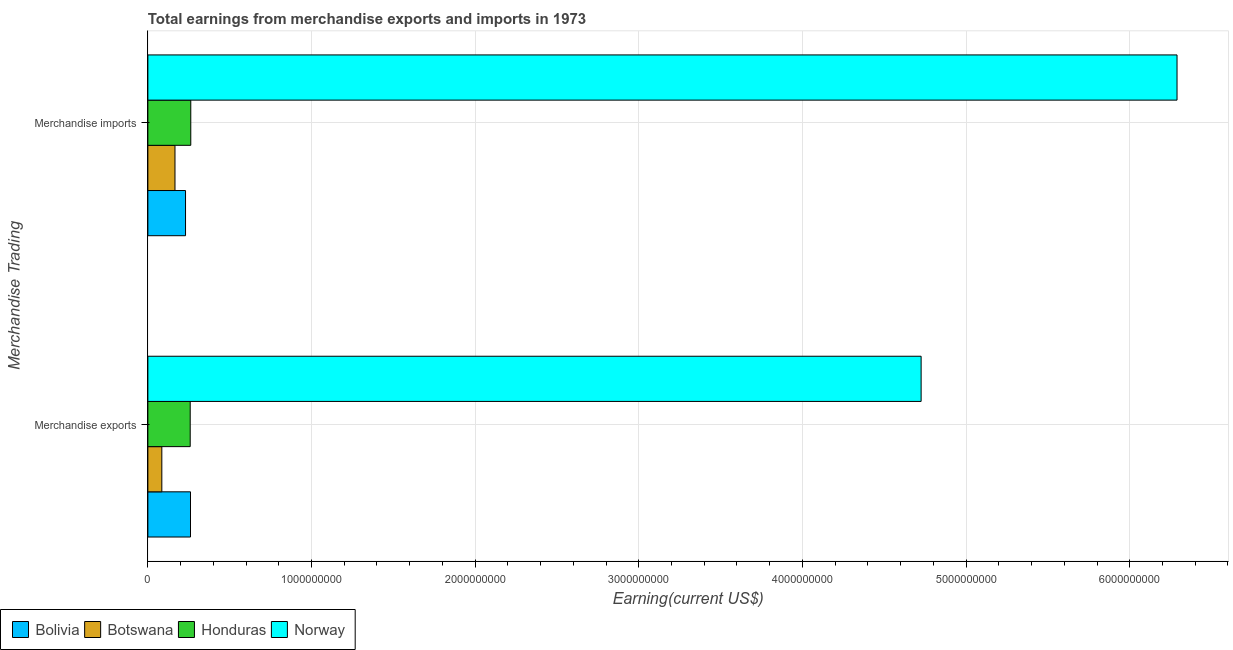How many different coloured bars are there?
Provide a succinct answer. 4. How many groups of bars are there?
Offer a terse response. 2. How many bars are there on the 1st tick from the top?
Provide a short and direct response. 4. What is the earnings from merchandise imports in Honduras?
Offer a very short reply. 2.62e+08. Across all countries, what is the maximum earnings from merchandise imports?
Keep it short and to the point. 6.29e+09. Across all countries, what is the minimum earnings from merchandise imports?
Make the answer very short. 1.66e+08. In which country was the earnings from merchandise exports maximum?
Make the answer very short. Norway. In which country was the earnings from merchandise imports minimum?
Your response must be concise. Botswana. What is the total earnings from merchandise imports in the graph?
Provide a succinct answer. 6.95e+09. What is the difference between the earnings from merchandise imports in Bolivia and that in Botswana?
Offer a very short reply. 6.45e+07. What is the difference between the earnings from merchandise exports in Botswana and the earnings from merchandise imports in Bolivia?
Your answer should be compact. -1.45e+08. What is the average earnings from merchandise imports per country?
Give a very brief answer. 1.74e+09. What is the difference between the earnings from merchandise exports and earnings from merchandise imports in Honduras?
Give a very brief answer. -3.54e+06. In how many countries, is the earnings from merchandise exports greater than 5800000000 US$?
Your response must be concise. 0. What is the ratio of the earnings from merchandise imports in Botswana to that in Norway?
Offer a very short reply. 0.03. In how many countries, is the earnings from merchandise imports greater than the average earnings from merchandise imports taken over all countries?
Provide a short and direct response. 1. What does the 2nd bar from the top in Merchandise exports represents?
Ensure brevity in your answer.  Honduras. What does the 3rd bar from the bottom in Merchandise exports represents?
Your answer should be compact. Honduras. Are all the bars in the graph horizontal?
Offer a very short reply. Yes. How many countries are there in the graph?
Keep it short and to the point. 4. What is the difference between two consecutive major ticks on the X-axis?
Ensure brevity in your answer.  1.00e+09. Does the graph contain any zero values?
Your answer should be compact. No. Does the graph contain grids?
Offer a very short reply. Yes. How many legend labels are there?
Your response must be concise. 4. What is the title of the graph?
Your answer should be very brief. Total earnings from merchandise exports and imports in 1973. Does "Sudan" appear as one of the legend labels in the graph?
Provide a succinct answer. No. What is the label or title of the X-axis?
Ensure brevity in your answer.  Earning(current US$). What is the label or title of the Y-axis?
Provide a succinct answer. Merchandise Trading. What is the Earning(current US$) of Bolivia in Merchandise exports?
Provide a short and direct response. 2.60e+08. What is the Earning(current US$) in Botswana in Merchandise exports?
Give a very brief answer. 8.53e+07. What is the Earning(current US$) of Honduras in Merchandise exports?
Your answer should be very brief. 2.59e+08. What is the Earning(current US$) in Norway in Merchandise exports?
Make the answer very short. 4.73e+09. What is the Earning(current US$) of Bolivia in Merchandise imports?
Make the answer very short. 2.30e+08. What is the Earning(current US$) in Botswana in Merchandise imports?
Your answer should be very brief. 1.66e+08. What is the Earning(current US$) of Honduras in Merchandise imports?
Make the answer very short. 2.62e+08. What is the Earning(current US$) of Norway in Merchandise imports?
Your response must be concise. 6.29e+09. Across all Merchandise Trading, what is the maximum Earning(current US$) in Bolivia?
Your answer should be compact. 2.60e+08. Across all Merchandise Trading, what is the maximum Earning(current US$) of Botswana?
Your answer should be compact. 1.66e+08. Across all Merchandise Trading, what is the maximum Earning(current US$) in Honduras?
Offer a very short reply. 2.62e+08. Across all Merchandise Trading, what is the maximum Earning(current US$) in Norway?
Give a very brief answer. 6.29e+09. Across all Merchandise Trading, what is the minimum Earning(current US$) of Bolivia?
Provide a succinct answer. 2.30e+08. Across all Merchandise Trading, what is the minimum Earning(current US$) in Botswana?
Make the answer very short. 8.53e+07. Across all Merchandise Trading, what is the minimum Earning(current US$) in Honduras?
Give a very brief answer. 2.59e+08. Across all Merchandise Trading, what is the minimum Earning(current US$) in Norway?
Make the answer very short. 4.73e+09. What is the total Earning(current US$) of Bolivia in the graph?
Provide a short and direct response. 4.91e+08. What is the total Earning(current US$) of Botswana in the graph?
Give a very brief answer. 2.51e+08. What is the total Earning(current US$) of Honduras in the graph?
Provide a short and direct response. 5.21e+08. What is the total Earning(current US$) in Norway in the graph?
Provide a short and direct response. 1.10e+1. What is the difference between the Earning(current US$) in Bolivia in Merchandise exports and that in Merchandise imports?
Offer a terse response. 3.03e+07. What is the difference between the Earning(current US$) of Botswana in Merchandise exports and that in Merchandise imports?
Offer a very short reply. -8.04e+07. What is the difference between the Earning(current US$) in Honduras in Merchandise exports and that in Merchandise imports?
Keep it short and to the point. -3.54e+06. What is the difference between the Earning(current US$) in Norway in Merchandise exports and that in Merchandise imports?
Give a very brief answer. -1.56e+09. What is the difference between the Earning(current US$) of Bolivia in Merchandise exports and the Earning(current US$) of Botswana in Merchandise imports?
Your answer should be compact. 9.48e+07. What is the difference between the Earning(current US$) in Bolivia in Merchandise exports and the Earning(current US$) in Honduras in Merchandise imports?
Offer a terse response. -1.78e+06. What is the difference between the Earning(current US$) in Bolivia in Merchandise exports and the Earning(current US$) in Norway in Merchandise imports?
Offer a very short reply. -6.03e+09. What is the difference between the Earning(current US$) in Botswana in Merchandise exports and the Earning(current US$) in Honduras in Merchandise imports?
Ensure brevity in your answer.  -1.77e+08. What is the difference between the Earning(current US$) of Botswana in Merchandise exports and the Earning(current US$) of Norway in Merchandise imports?
Your response must be concise. -6.20e+09. What is the difference between the Earning(current US$) in Honduras in Merchandise exports and the Earning(current US$) in Norway in Merchandise imports?
Make the answer very short. -6.03e+09. What is the average Earning(current US$) of Bolivia per Merchandise Trading?
Give a very brief answer. 2.45e+08. What is the average Earning(current US$) of Botswana per Merchandise Trading?
Give a very brief answer. 1.25e+08. What is the average Earning(current US$) of Honduras per Merchandise Trading?
Your response must be concise. 2.61e+08. What is the average Earning(current US$) in Norway per Merchandise Trading?
Your answer should be compact. 5.51e+09. What is the difference between the Earning(current US$) of Bolivia and Earning(current US$) of Botswana in Merchandise exports?
Your answer should be very brief. 1.75e+08. What is the difference between the Earning(current US$) in Bolivia and Earning(current US$) in Honduras in Merchandise exports?
Your answer should be compact. 1.76e+06. What is the difference between the Earning(current US$) of Bolivia and Earning(current US$) of Norway in Merchandise exports?
Give a very brief answer. -4.46e+09. What is the difference between the Earning(current US$) in Botswana and Earning(current US$) in Honduras in Merchandise exports?
Offer a very short reply. -1.73e+08. What is the difference between the Earning(current US$) of Botswana and Earning(current US$) of Norway in Merchandise exports?
Give a very brief answer. -4.64e+09. What is the difference between the Earning(current US$) of Honduras and Earning(current US$) of Norway in Merchandise exports?
Offer a very short reply. -4.47e+09. What is the difference between the Earning(current US$) of Bolivia and Earning(current US$) of Botswana in Merchandise imports?
Provide a succinct answer. 6.45e+07. What is the difference between the Earning(current US$) of Bolivia and Earning(current US$) of Honduras in Merchandise imports?
Keep it short and to the point. -3.21e+07. What is the difference between the Earning(current US$) in Bolivia and Earning(current US$) in Norway in Merchandise imports?
Make the answer very short. -6.06e+09. What is the difference between the Earning(current US$) of Botswana and Earning(current US$) of Honduras in Merchandise imports?
Ensure brevity in your answer.  -9.66e+07. What is the difference between the Earning(current US$) in Botswana and Earning(current US$) in Norway in Merchandise imports?
Ensure brevity in your answer.  -6.12e+09. What is the difference between the Earning(current US$) in Honduras and Earning(current US$) in Norway in Merchandise imports?
Keep it short and to the point. -6.03e+09. What is the ratio of the Earning(current US$) in Bolivia in Merchandise exports to that in Merchandise imports?
Your answer should be compact. 1.13. What is the ratio of the Earning(current US$) of Botswana in Merchandise exports to that in Merchandise imports?
Your answer should be compact. 0.51. What is the ratio of the Earning(current US$) of Honduras in Merchandise exports to that in Merchandise imports?
Your answer should be compact. 0.99. What is the ratio of the Earning(current US$) in Norway in Merchandise exports to that in Merchandise imports?
Offer a terse response. 0.75. What is the difference between the highest and the second highest Earning(current US$) of Bolivia?
Give a very brief answer. 3.03e+07. What is the difference between the highest and the second highest Earning(current US$) in Botswana?
Keep it short and to the point. 8.04e+07. What is the difference between the highest and the second highest Earning(current US$) in Honduras?
Your answer should be compact. 3.54e+06. What is the difference between the highest and the second highest Earning(current US$) of Norway?
Give a very brief answer. 1.56e+09. What is the difference between the highest and the lowest Earning(current US$) of Bolivia?
Offer a very short reply. 3.03e+07. What is the difference between the highest and the lowest Earning(current US$) of Botswana?
Keep it short and to the point. 8.04e+07. What is the difference between the highest and the lowest Earning(current US$) in Honduras?
Your answer should be compact. 3.54e+06. What is the difference between the highest and the lowest Earning(current US$) in Norway?
Make the answer very short. 1.56e+09. 